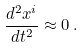Convert formula to latex. <formula><loc_0><loc_0><loc_500><loc_500>\frac { d ^ { 2 } x ^ { i } } { d t ^ { 2 } } \approx 0 \, .</formula> 